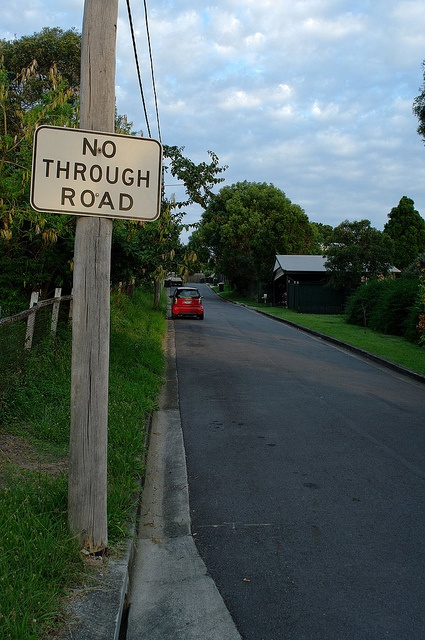Describe the objects in this image and their specific colors. I can see car in lightblue, black, maroon, and purple tones and car in lightblue, black, and gray tones in this image. 